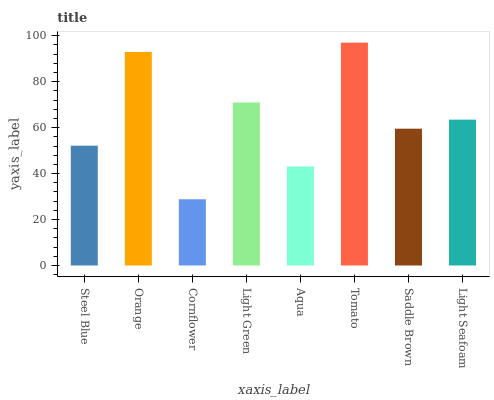Is Cornflower the minimum?
Answer yes or no. Yes. Is Tomato the maximum?
Answer yes or no. Yes. Is Orange the minimum?
Answer yes or no. No. Is Orange the maximum?
Answer yes or no. No. Is Orange greater than Steel Blue?
Answer yes or no. Yes. Is Steel Blue less than Orange?
Answer yes or no. Yes. Is Steel Blue greater than Orange?
Answer yes or no. No. Is Orange less than Steel Blue?
Answer yes or no. No. Is Light Seafoam the high median?
Answer yes or no. Yes. Is Saddle Brown the low median?
Answer yes or no. Yes. Is Orange the high median?
Answer yes or no. No. Is Steel Blue the low median?
Answer yes or no. No. 